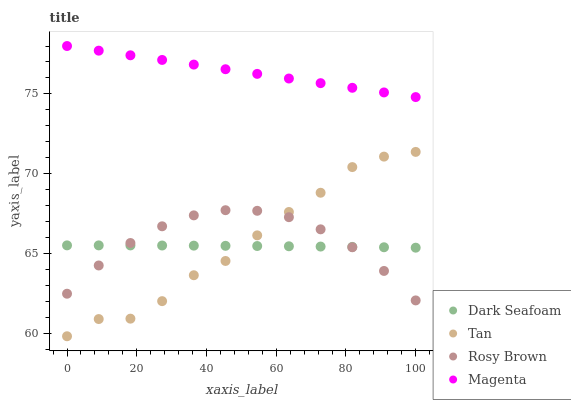Does Dark Seafoam have the minimum area under the curve?
Answer yes or no. Yes. Does Magenta have the maximum area under the curve?
Answer yes or no. Yes. Does Rosy Brown have the minimum area under the curve?
Answer yes or no. No. Does Rosy Brown have the maximum area under the curve?
Answer yes or no. No. Is Magenta the smoothest?
Answer yes or no. Yes. Is Tan the roughest?
Answer yes or no. Yes. Is Rosy Brown the smoothest?
Answer yes or no. No. Is Rosy Brown the roughest?
Answer yes or no. No. Does Tan have the lowest value?
Answer yes or no. Yes. Does Rosy Brown have the lowest value?
Answer yes or no. No. Does Magenta have the highest value?
Answer yes or no. Yes. Does Rosy Brown have the highest value?
Answer yes or no. No. Is Dark Seafoam less than Magenta?
Answer yes or no. Yes. Is Magenta greater than Rosy Brown?
Answer yes or no. Yes. Does Rosy Brown intersect Tan?
Answer yes or no. Yes. Is Rosy Brown less than Tan?
Answer yes or no. No. Is Rosy Brown greater than Tan?
Answer yes or no. No. Does Dark Seafoam intersect Magenta?
Answer yes or no. No. 